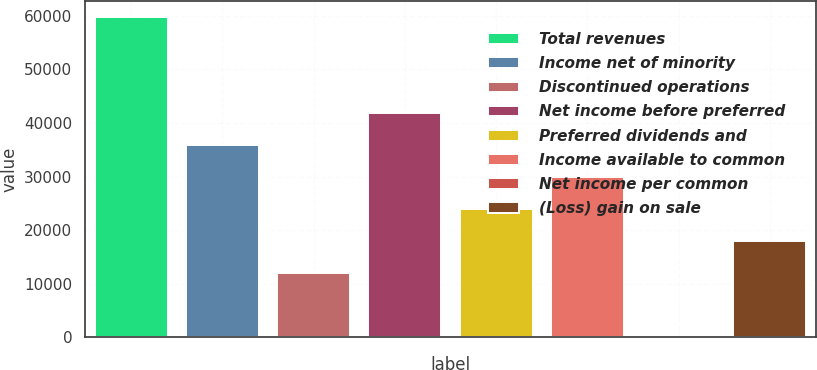Convert chart to OTSL. <chart><loc_0><loc_0><loc_500><loc_500><bar_chart><fcel>Total revenues<fcel>Income net of minority<fcel>Discontinued operations<fcel>Net income before preferred<fcel>Preferred dividends and<fcel>Income available to common<fcel>Net income per common<fcel>(Loss) gain on sale<nl><fcel>59723<fcel>35834<fcel>11945<fcel>41806.2<fcel>23889.5<fcel>29861.8<fcel>0.5<fcel>17917.2<nl></chart> 